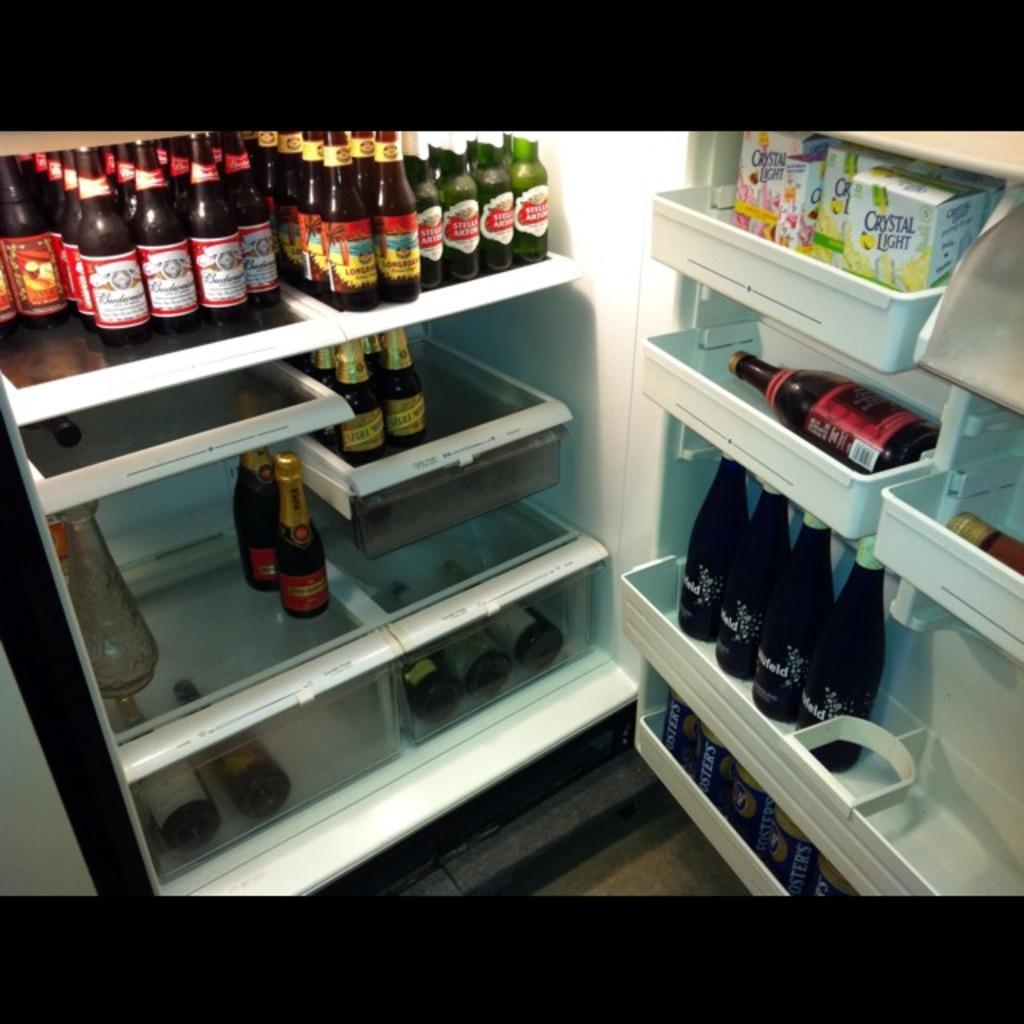What type of containers are visible in the image? There are bottles and cardboard boxes in the image. Where are the bottles and cardboard boxes located? The bottles and cardboard boxes are inside a refrigerator. What color is the crayon used to draw on the cardboard boxes in the image? There is no crayon or drawing present on the cardboard boxes in the image. How many people are joining the refrigerator in the image? The image does not show any people, so it is not possible to determine how many people might be joining the refrigerator. 